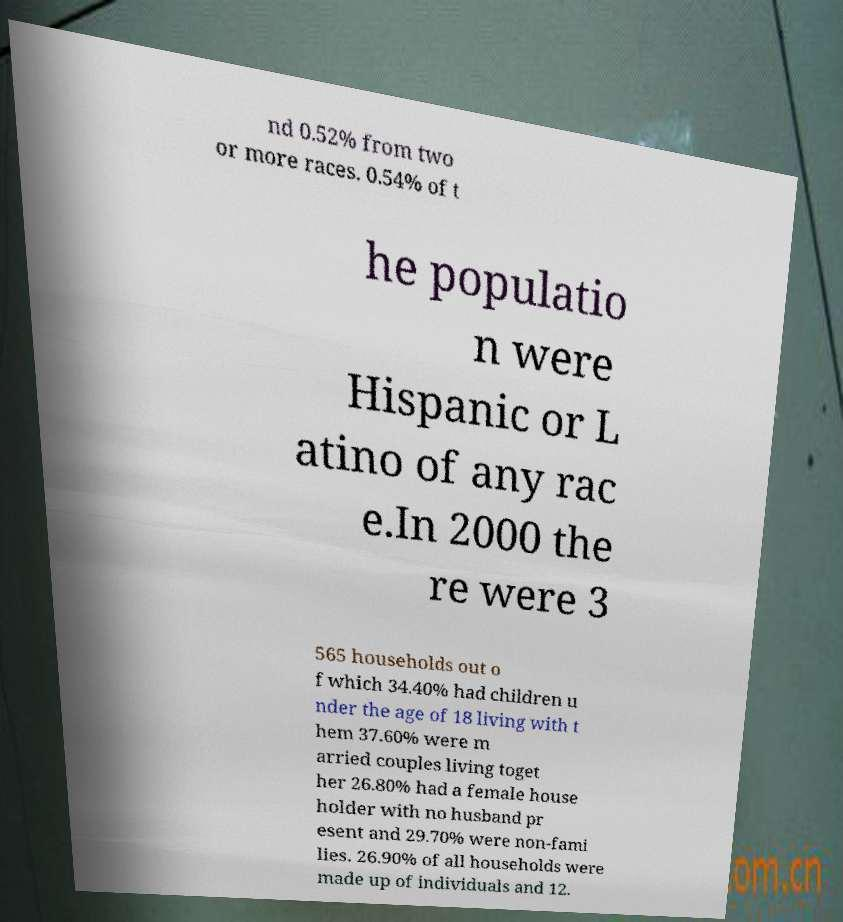For documentation purposes, I need the text within this image transcribed. Could you provide that? nd 0.52% from two or more races. 0.54% of t he populatio n were Hispanic or L atino of any rac e.In 2000 the re were 3 565 households out o f which 34.40% had children u nder the age of 18 living with t hem 37.60% were m arried couples living toget her 26.80% had a female house holder with no husband pr esent and 29.70% were non-fami lies. 26.90% of all households were made up of individuals and 12. 